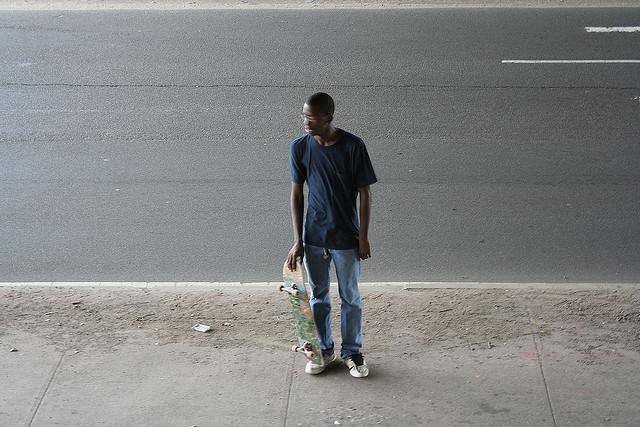How many people can you see?
Give a very brief answer. 1. 